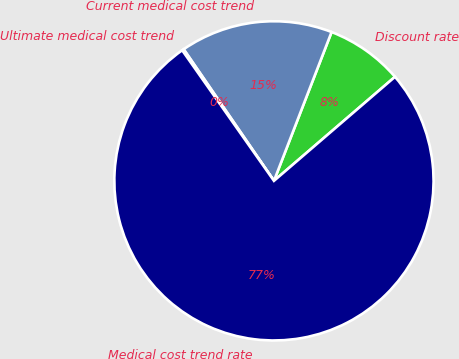Convert chart. <chart><loc_0><loc_0><loc_500><loc_500><pie_chart><fcel>Discount rate<fcel>Current medical cost trend<fcel>Ultimate medical cost trend<fcel>Medical cost trend rate<nl><fcel>7.82%<fcel>15.45%<fcel>0.18%<fcel>76.55%<nl></chart> 